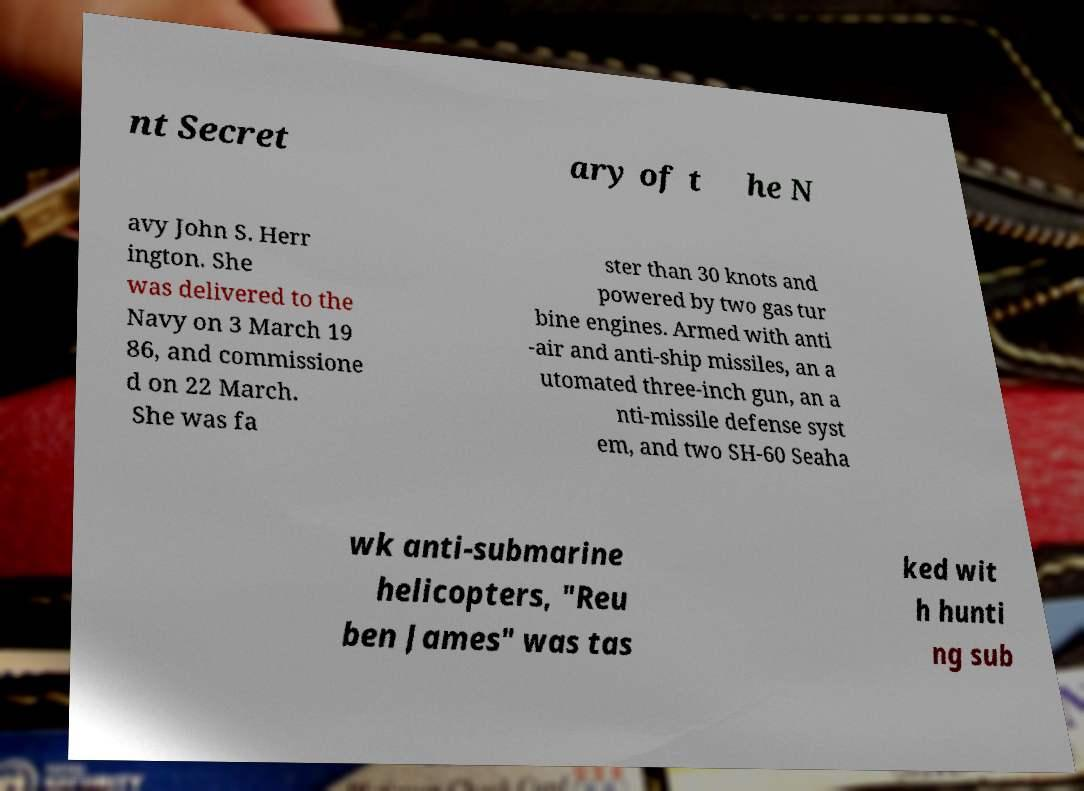For documentation purposes, I need the text within this image transcribed. Could you provide that? nt Secret ary of t he N avy John S. Herr ington. She was delivered to the Navy on 3 March 19 86, and commissione d on 22 March. She was fa ster than 30 knots and powered by two gas tur bine engines. Armed with anti -air and anti-ship missiles, an a utomated three-inch gun, an a nti-missile defense syst em, and two SH-60 Seaha wk anti-submarine helicopters, "Reu ben James" was tas ked wit h hunti ng sub 